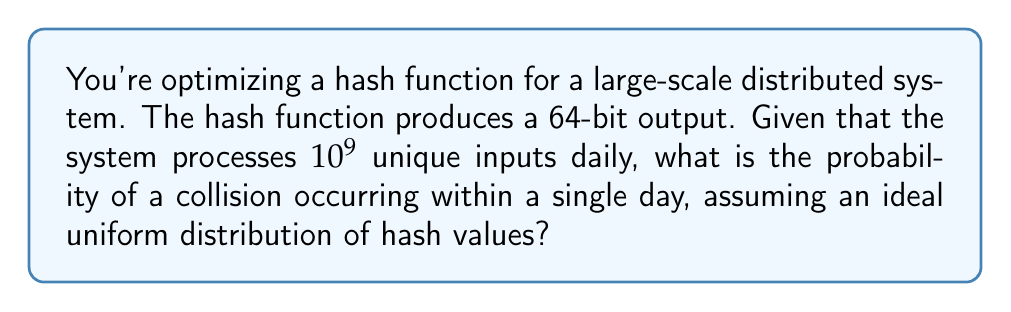Help me with this question. Let's approach this step-by-step:

1) First, we need to understand the birthday problem, which is relevant to hash collision probability.

2) The number of possible hash values is $2^{64}$, as it's a 64-bit hash.

3) The number of inputs is $n = 10^9$.

4) The probability of no collision is given by:

   $$P(\text{no collision}) = \frac{2^{64}!}{(2^{64}-n)! \cdot 2^{64n}}$$

5) For large values, this is approximated by:

   $$P(\text{no collision}) \approx e^{-\frac{n(n-1)}{2^{65}}}$$

6) Therefore, the probability of a collision is:

   $$P(\text{collision}) = 1 - P(\text{no collision}) \approx 1 - e^{-\frac{n(n-1)}{2^{65}}}$$

7) Substituting our values:

   $$P(\text{collision}) \approx 1 - e^{-\frac{10^9(10^9-1)}{2^{65}}}$$

8) Simplifying:

   $$P(\text{collision}) \approx 1 - e^{-\frac{10^{18}}{2^{65}}} \approx 1 - e^{-2.7 \times 10^{-5}} \approx 2.7 \times 10^{-5}$$

This probability is quite low, indicating that the 64-bit hash function is reasonably secure for this use case.
Answer: $2.7 \times 10^{-5}$ 